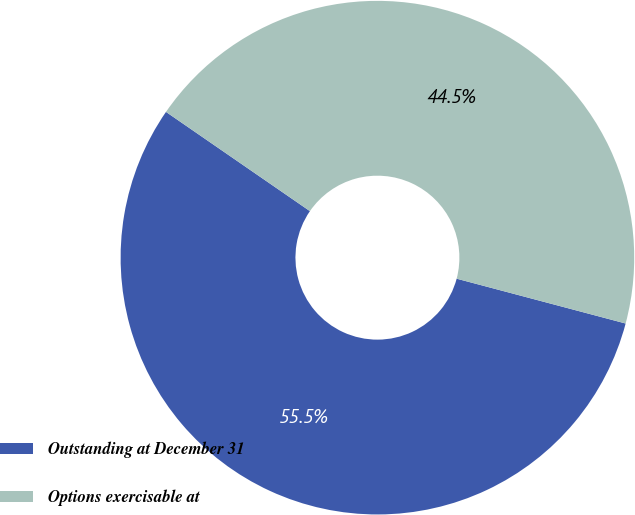Convert chart. <chart><loc_0><loc_0><loc_500><loc_500><pie_chart><fcel>Outstanding at December 31<fcel>Options exercisable at<nl><fcel>55.48%<fcel>44.52%<nl></chart> 